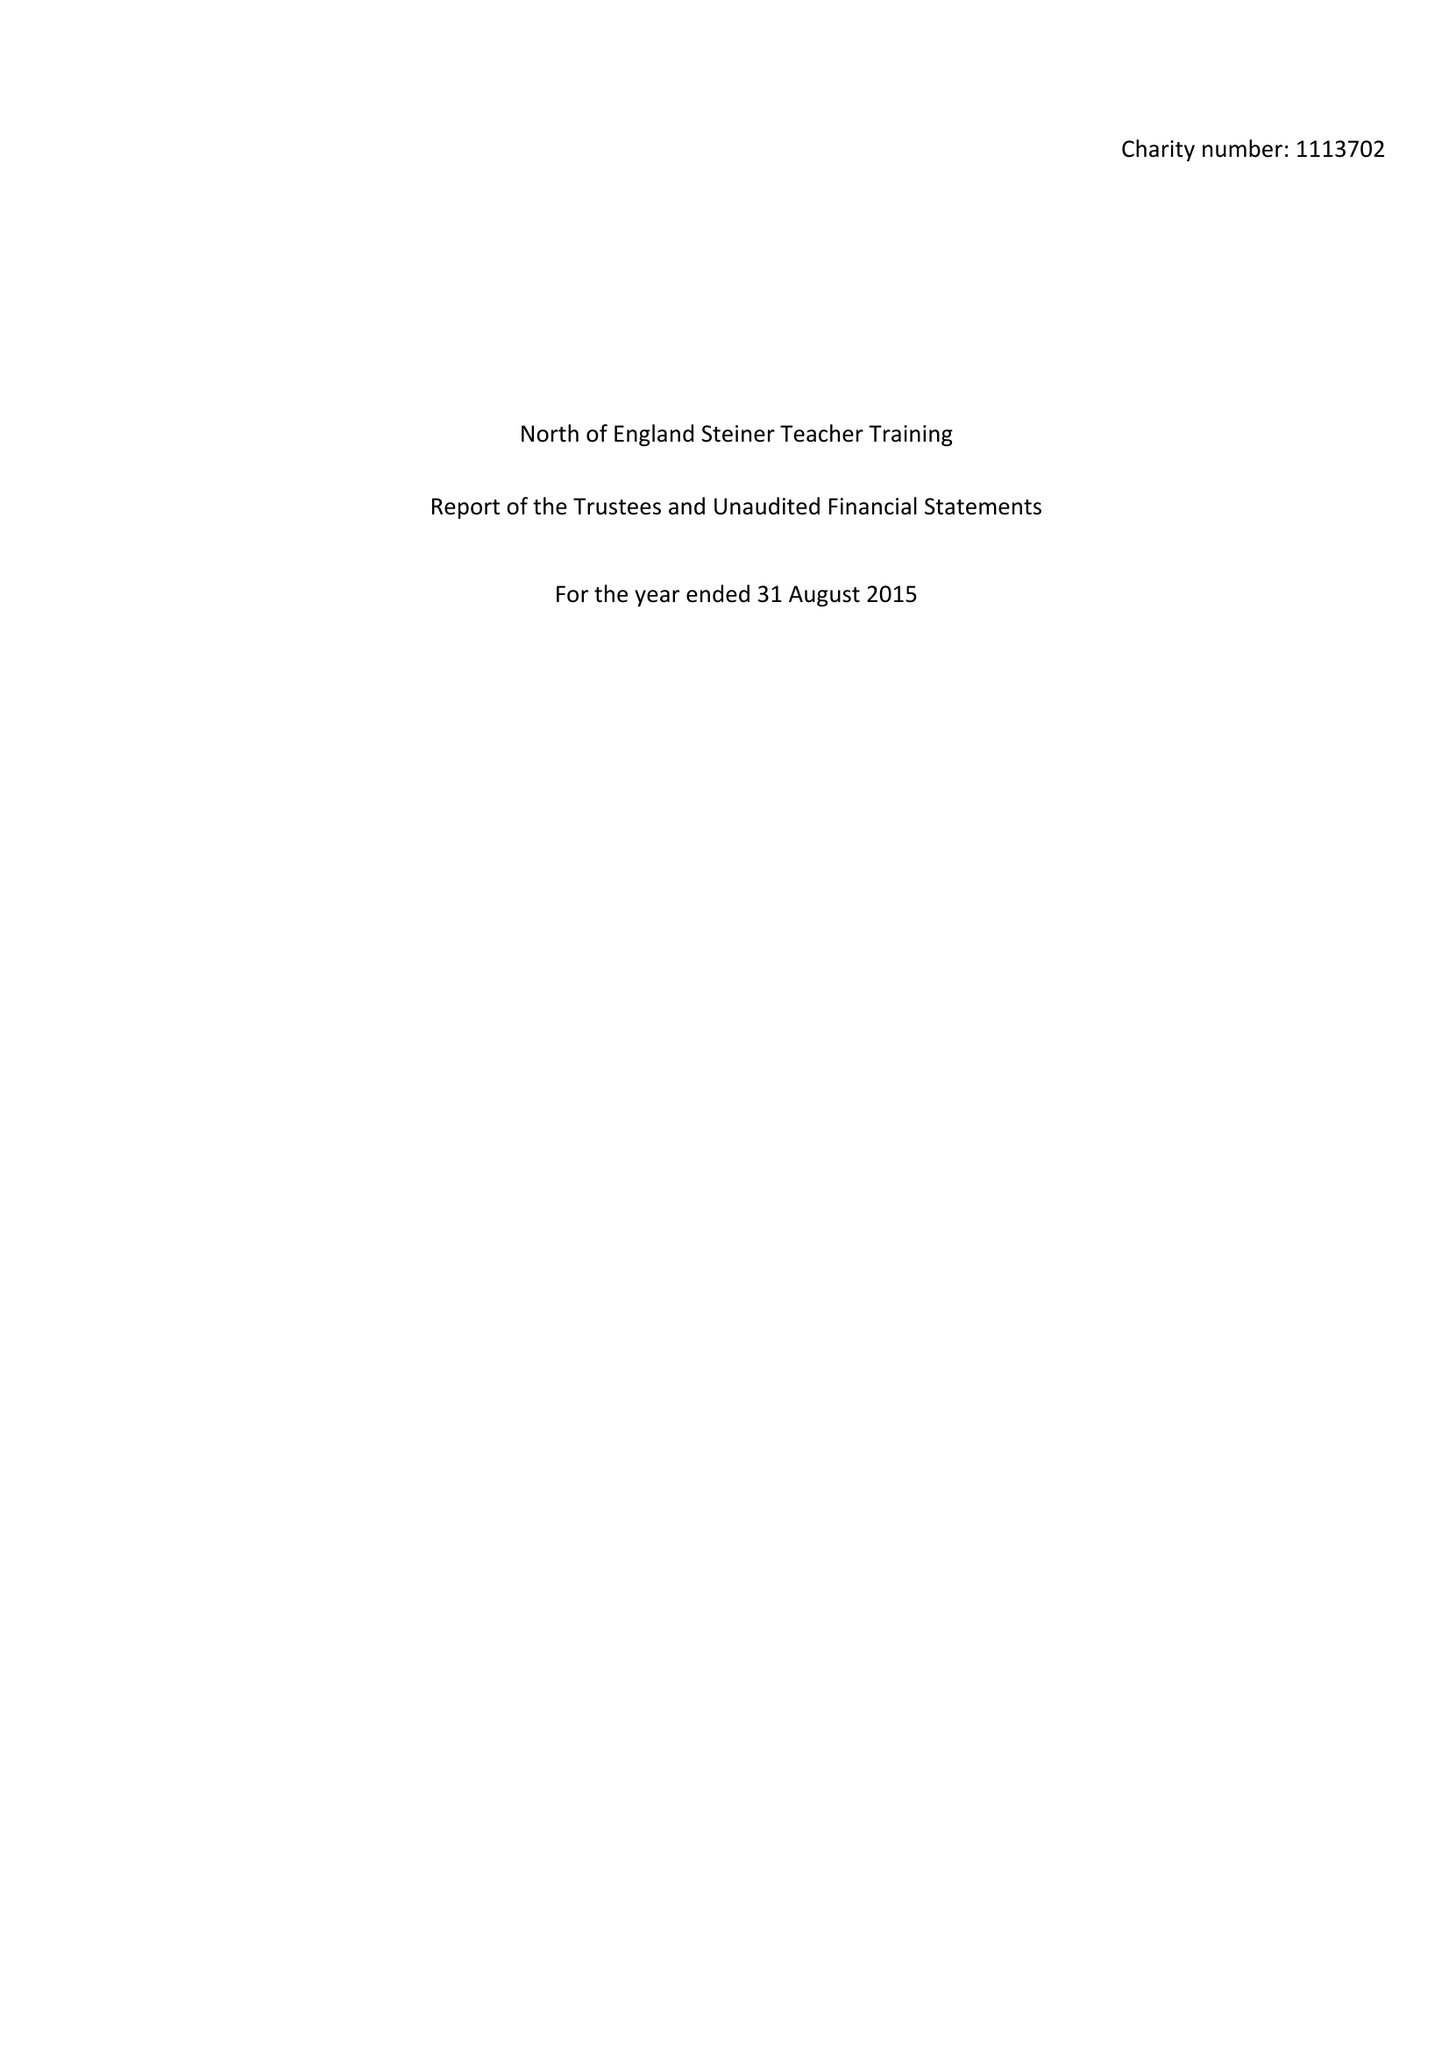What is the value for the report_date?
Answer the question using a single word or phrase. 2015-08-31 